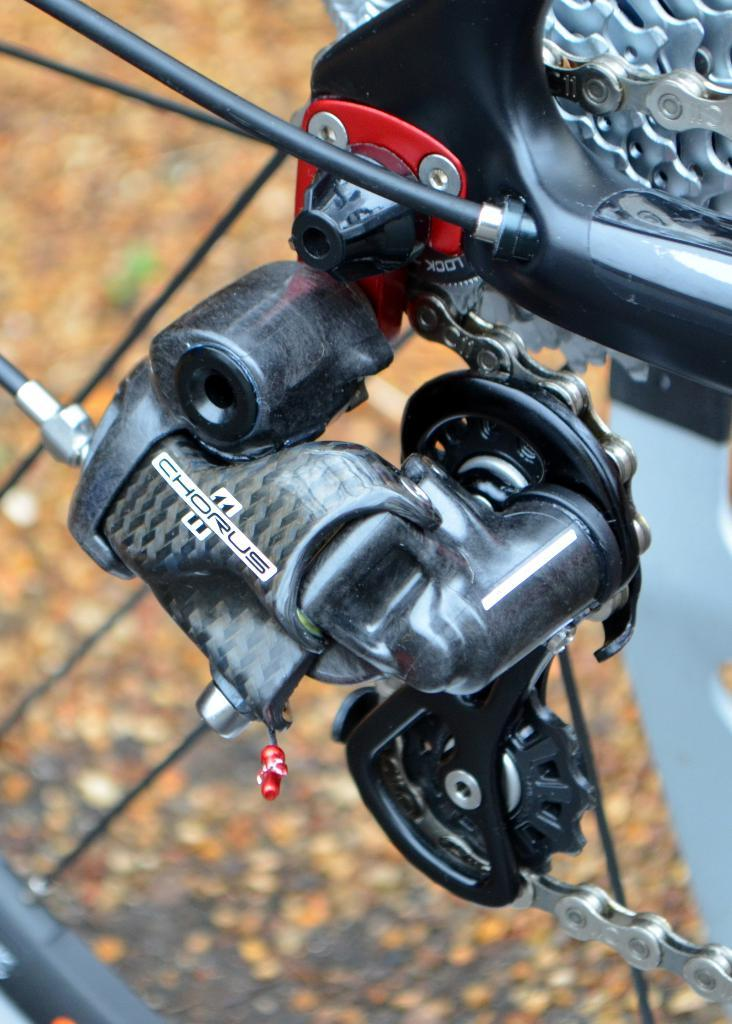What is the main subject in the foreground of the image? There is a cycle chain in the foreground of the image. What is connected to the cycle chain? The cycle chain appears to be connected to an engine. What can be seen in the background of the image? There are leaves visible in the background of the image. What type of insurance is required for the unit in the image? There is no unit present in the image, so the question of insurance is not applicable. 